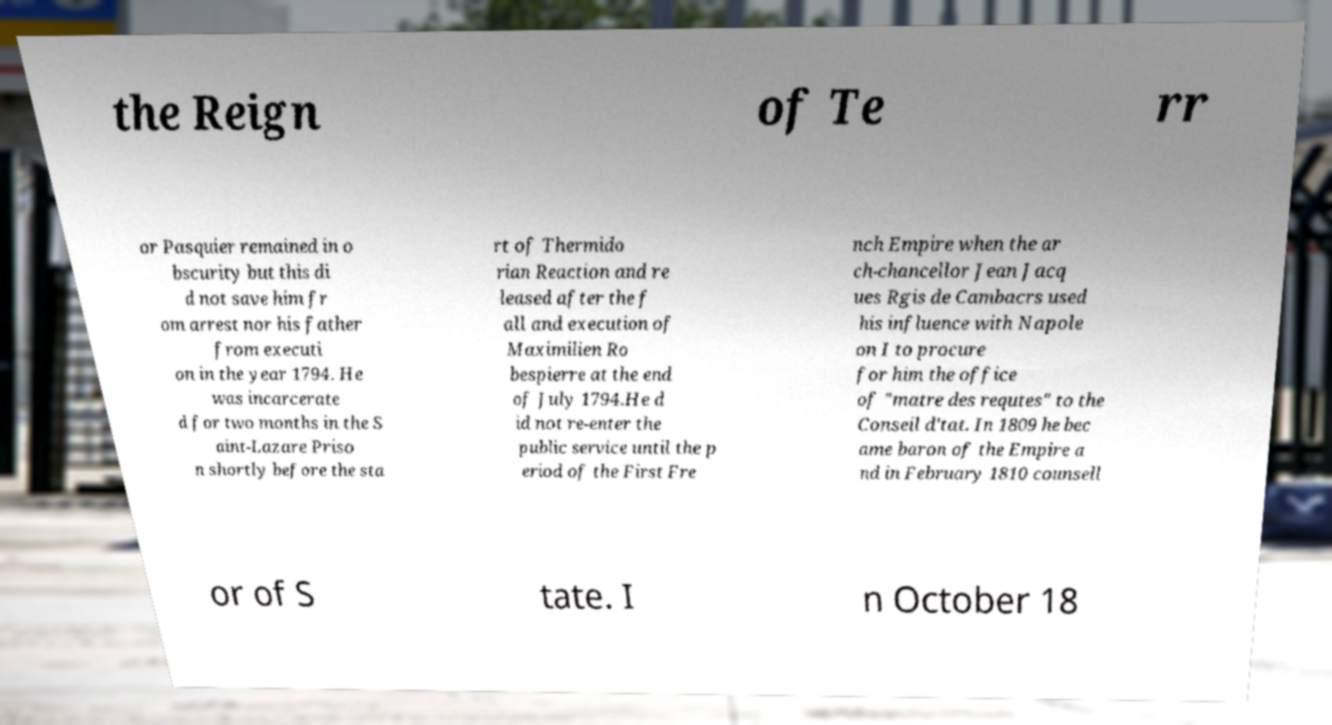I need the written content from this picture converted into text. Can you do that? the Reign of Te rr or Pasquier remained in o bscurity but this di d not save him fr om arrest nor his father from executi on in the year 1794. He was incarcerate d for two months in the S aint-Lazare Priso n shortly before the sta rt of Thermido rian Reaction and re leased after the f all and execution of Maximilien Ro bespierre at the end of July 1794.He d id not re-enter the public service until the p eriod of the First Fre nch Empire when the ar ch-chancellor Jean Jacq ues Rgis de Cambacrs used his influence with Napole on I to procure for him the office of "matre des requtes" to the Conseil d'tat. In 1809 he bec ame baron of the Empire a nd in February 1810 counsell or of S tate. I n October 18 